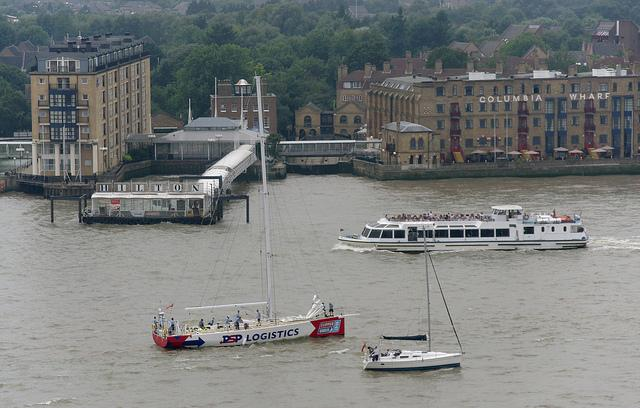In what country is this river in? england 